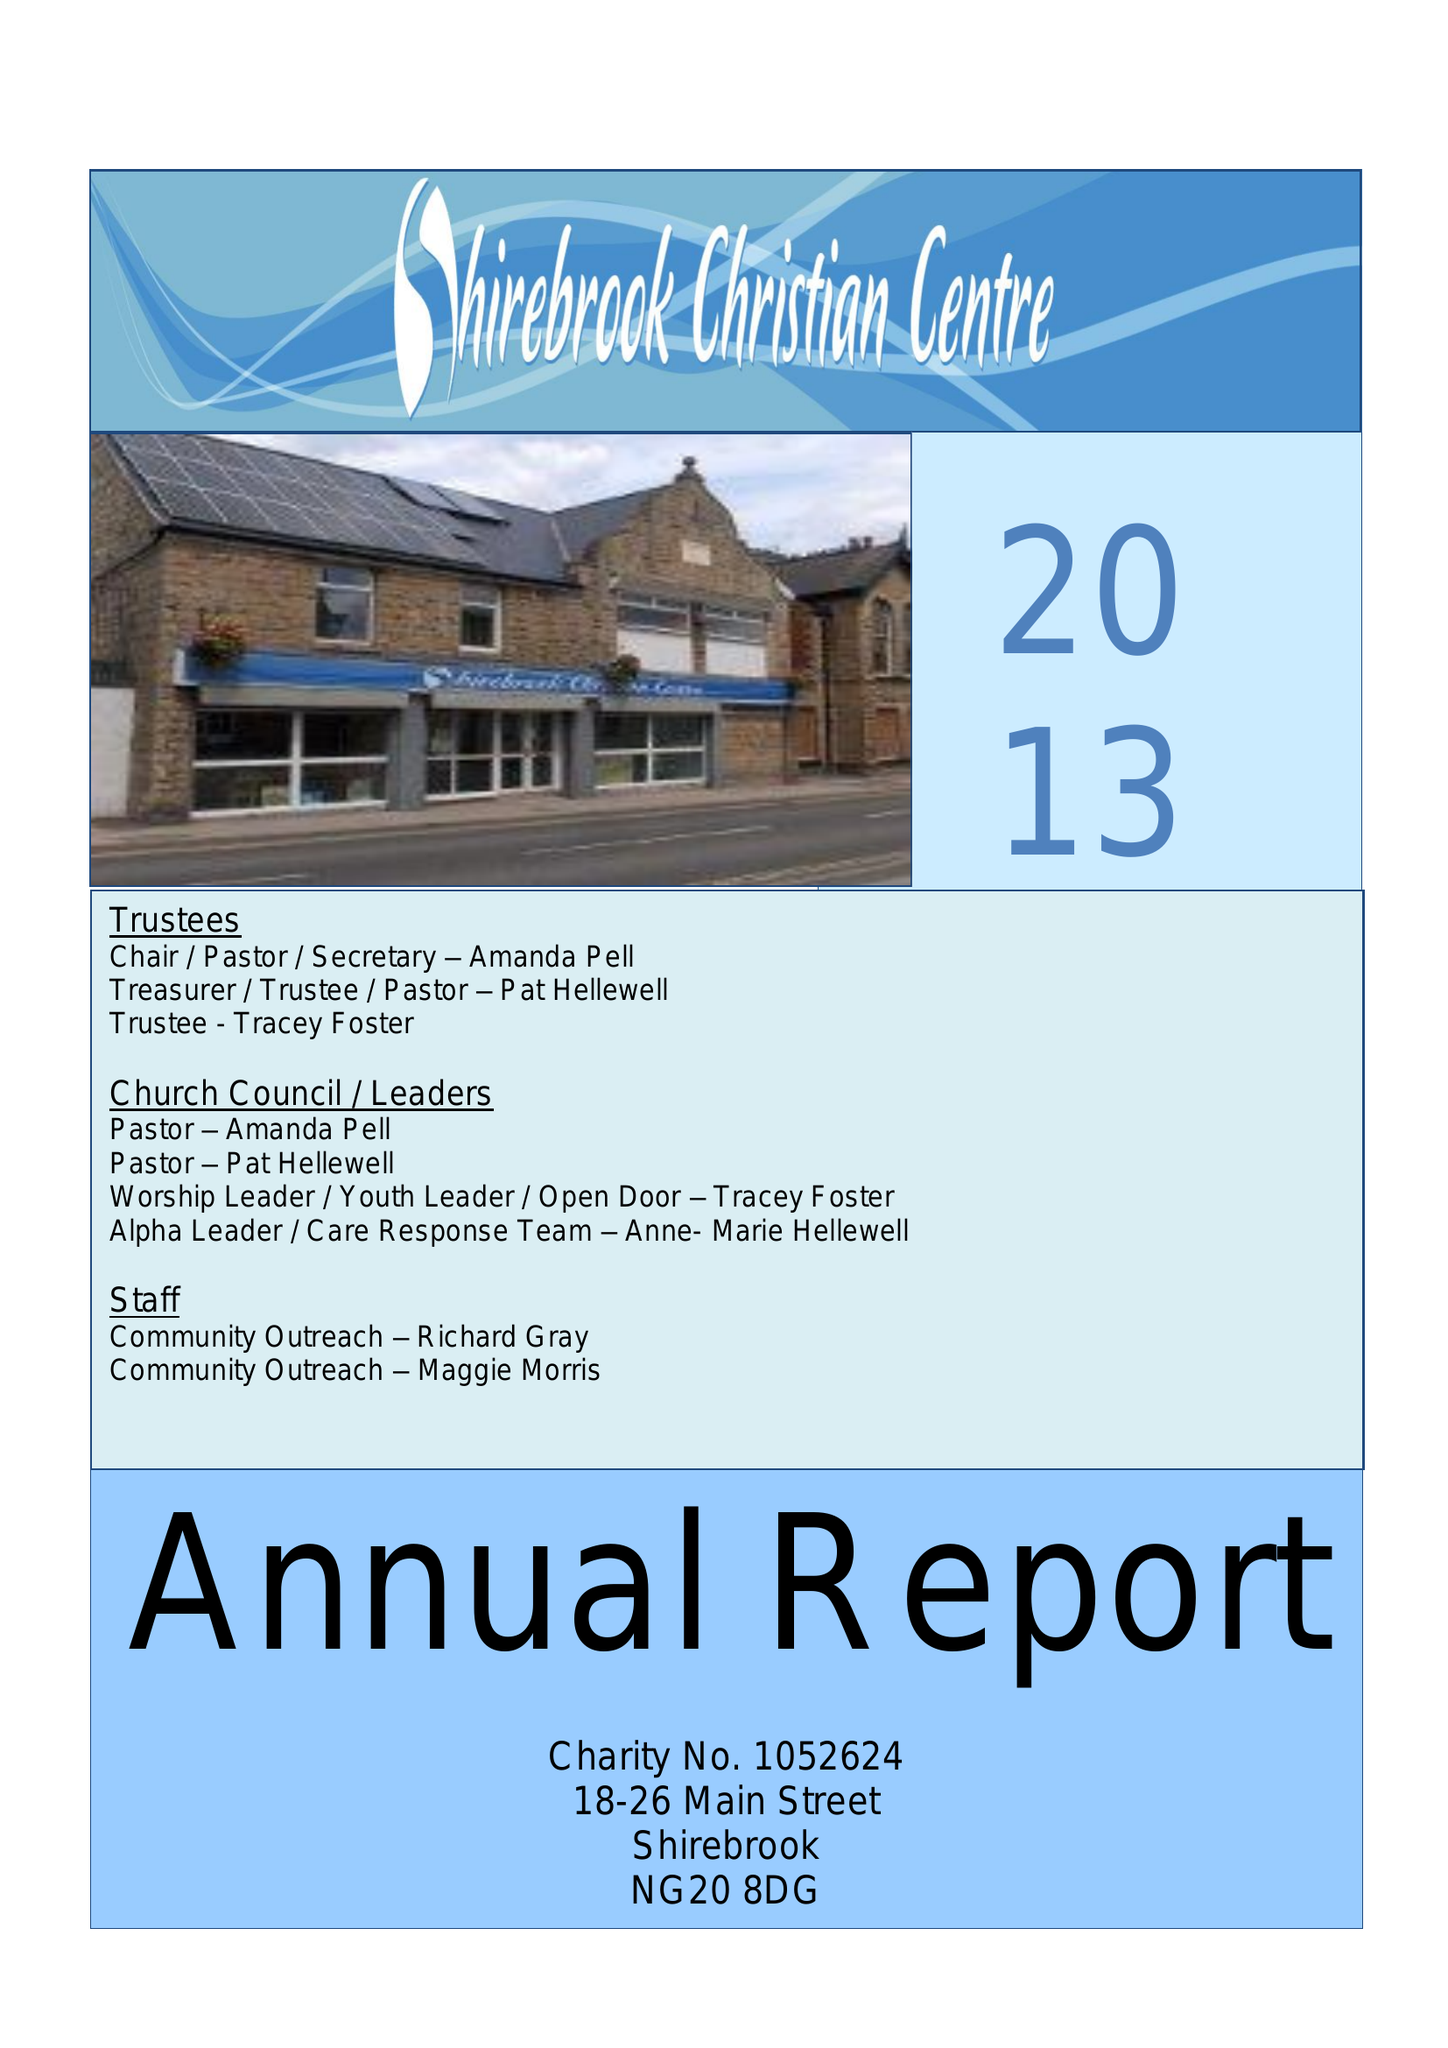What is the value for the address__street_line?
Answer the question using a single word or phrase. None 